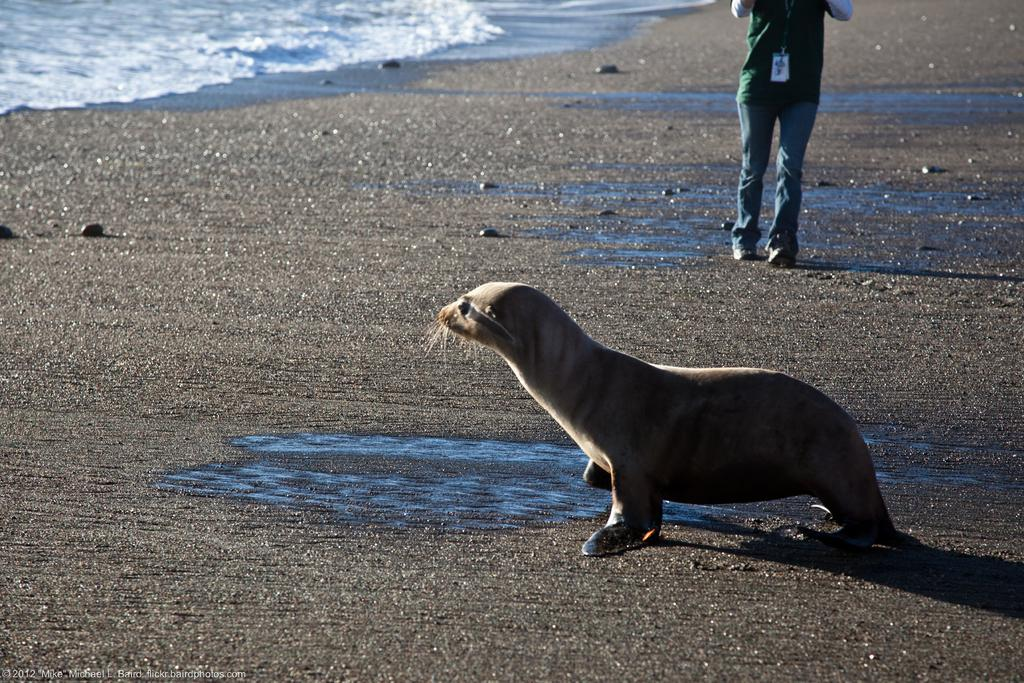What type of animal is in the image? There is a seal in the image. Is there a person present in the image? Yes, there is a person in the image. What can be seen beneath the subjects in the image? The ground is visible in the image. What is visible in the background of the image? There is water visible in the background of the image. What type of yoke is being used by the seal in the image? There is no yoke present in the image, as it features a seal and a person in a natural setting. 